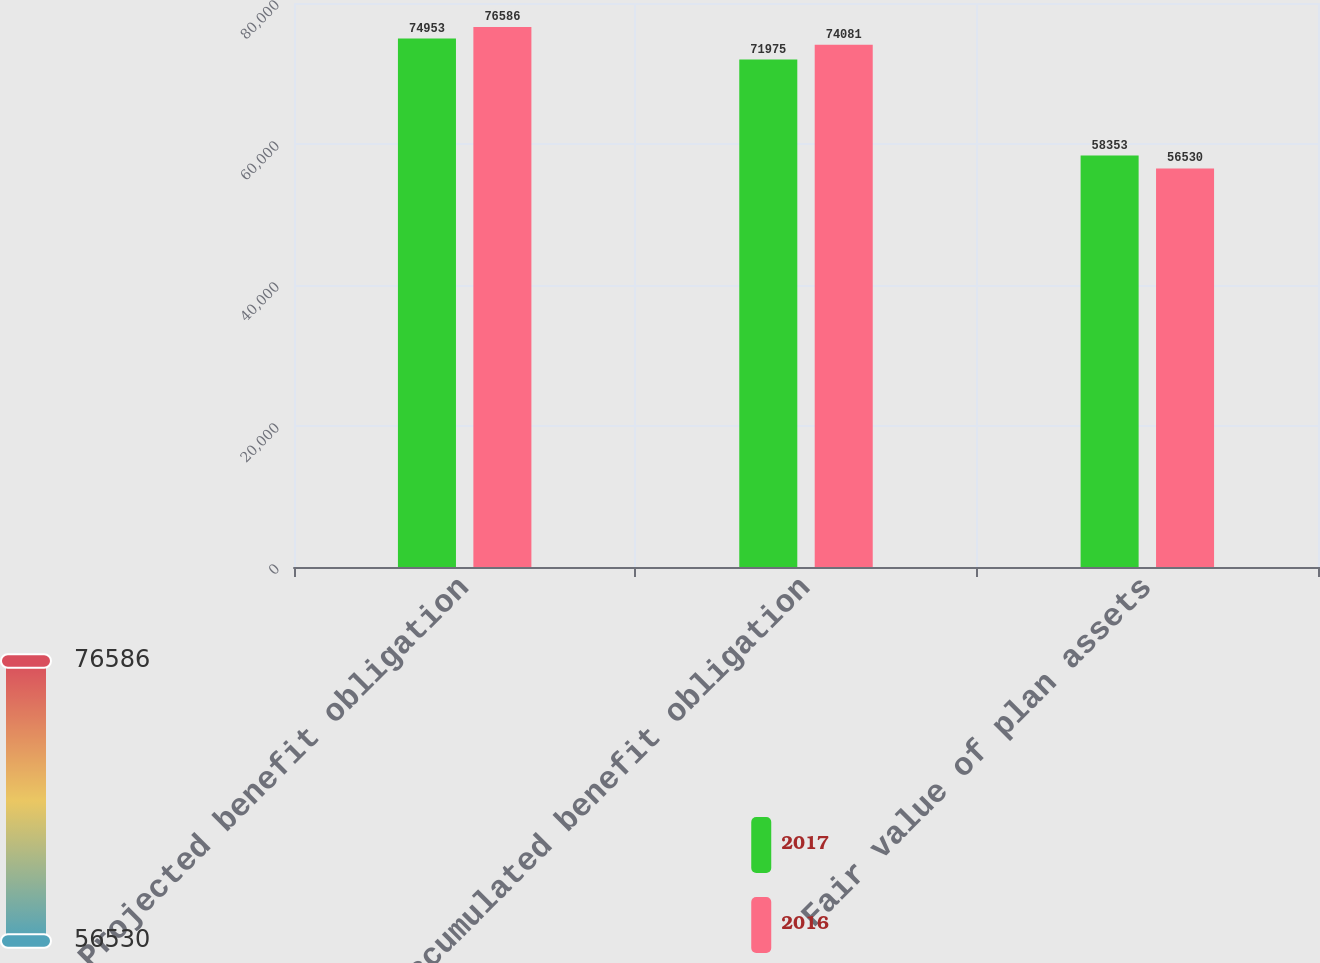<chart> <loc_0><loc_0><loc_500><loc_500><stacked_bar_chart><ecel><fcel>Projected benefit obligation<fcel>Accumulated benefit obligation<fcel>Fair value of plan assets<nl><fcel>2017<fcel>74953<fcel>71975<fcel>58353<nl><fcel>2016<fcel>76586<fcel>74081<fcel>56530<nl></chart> 